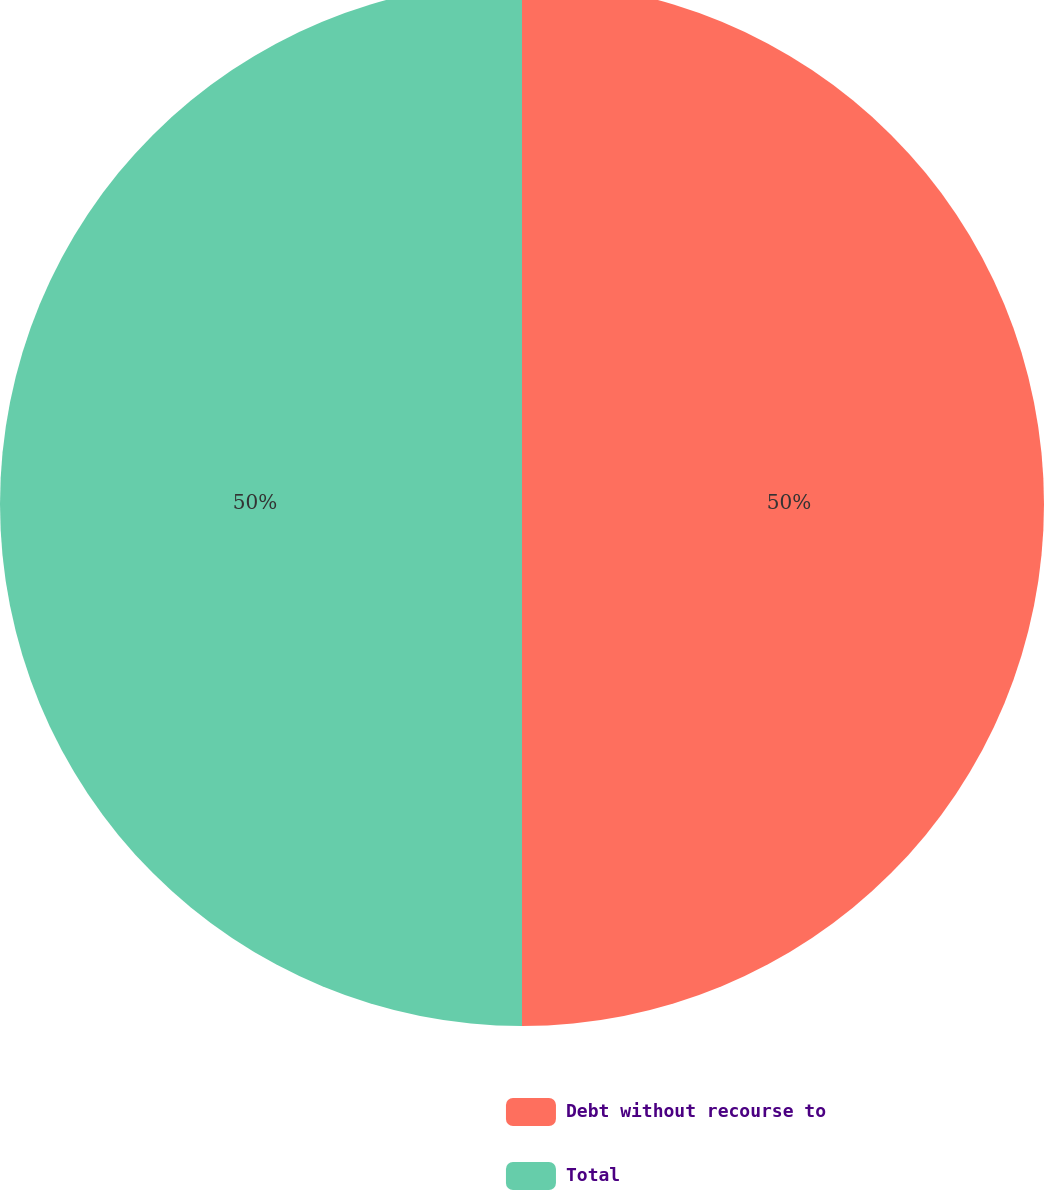<chart> <loc_0><loc_0><loc_500><loc_500><pie_chart><fcel>Debt without recourse to<fcel>Total<nl><fcel>50.0%<fcel>50.0%<nl></chart> 